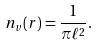Convert formula to latex. <formula><loc_0><loc_0><loc_500><loc_500>n _ { v } ( { r } ) = \frac { 1 } { \pi \ell ^ { 2 } } .</formula> 